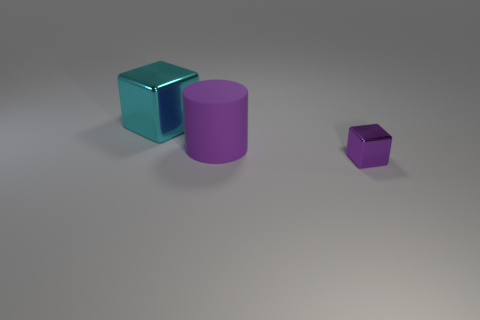What color is the big thing on the left side of the big thing that is in front of the cyan shiny object?
Your answer should be compact. Cyan. Do the tiny shiny block and the shiny block behind the purple rubber cylinder have the same color?
Provide a short and direct response. No. There is a cyan block that is the same material as the tiny purple object; what is its size?
Your response must be concise. Large. There is a rubber cylinder that is the same color as the tiny cube; what is its size?
Keep it short and to the point. Large. Is the large shiny cube the same color as the tiny cube?
Keep it short and to the point. No. There is a big thing in front of the block that is behind the small shiny thing; are there any tiny metallic cubes left of it?
Make the answer very short. No. What number of rubber cylinders are the same size as the cyan object?
Keep it short and to the point. 1. Do the metallic block that is to the right of the purple cylinder and the purple cylinder that is on the right side of the big metallic cube have the same size?
Your response must be concise. No. Is there a big metal object that has the same color as the cylinder?
Make the answer very short. No. Are there any purple cylinders?
Keep it short and to the point. Yes. 